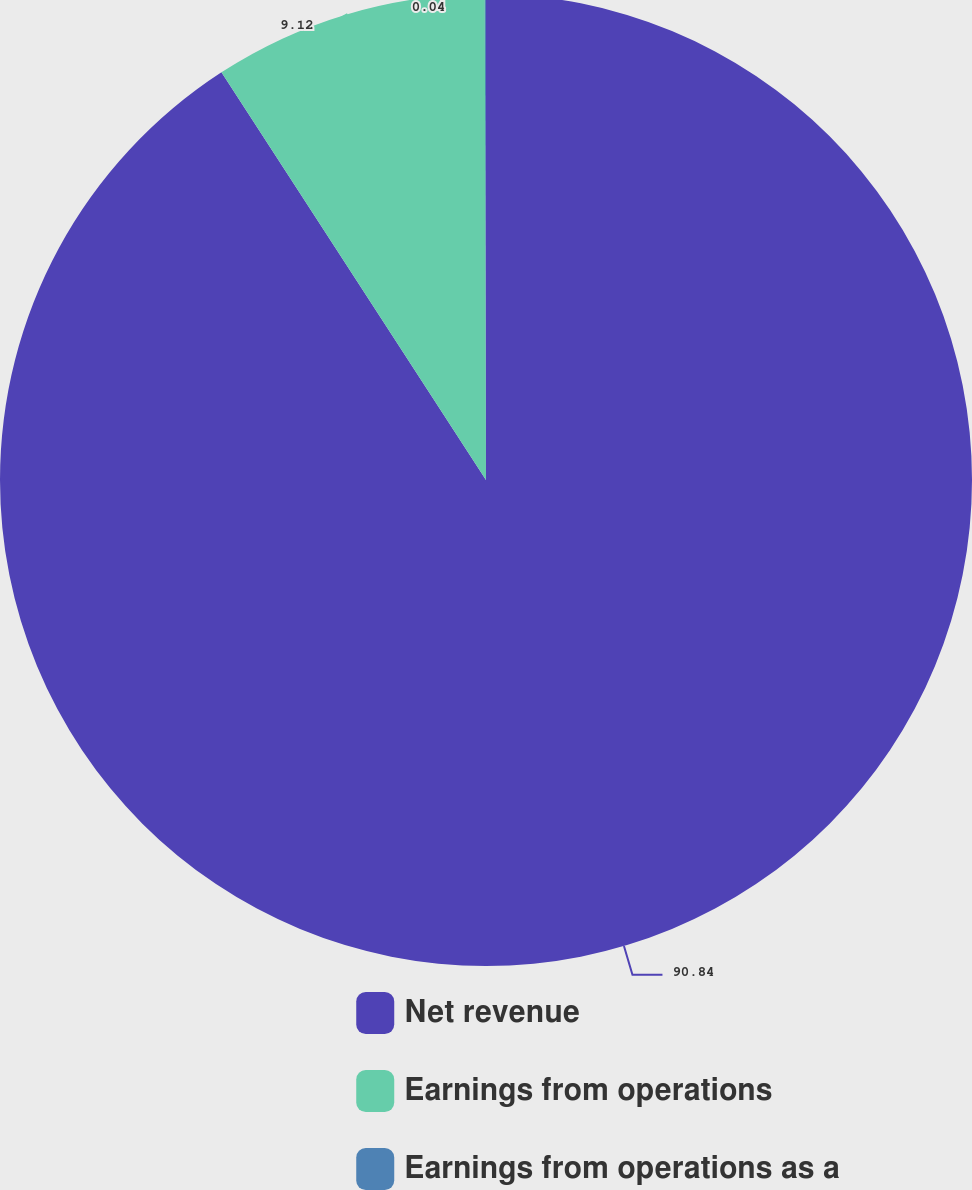Convert chart to OTSL. <chart><loc_0><loc_0><loc_500><loc_500><pie_chart><fcel>Net revenue<fcel>Earnings from operations<fcel>Earnings from operations as a<nl><fcel>90.83%<fcel>9.12%<fcel>0.04%<nl></chart> 